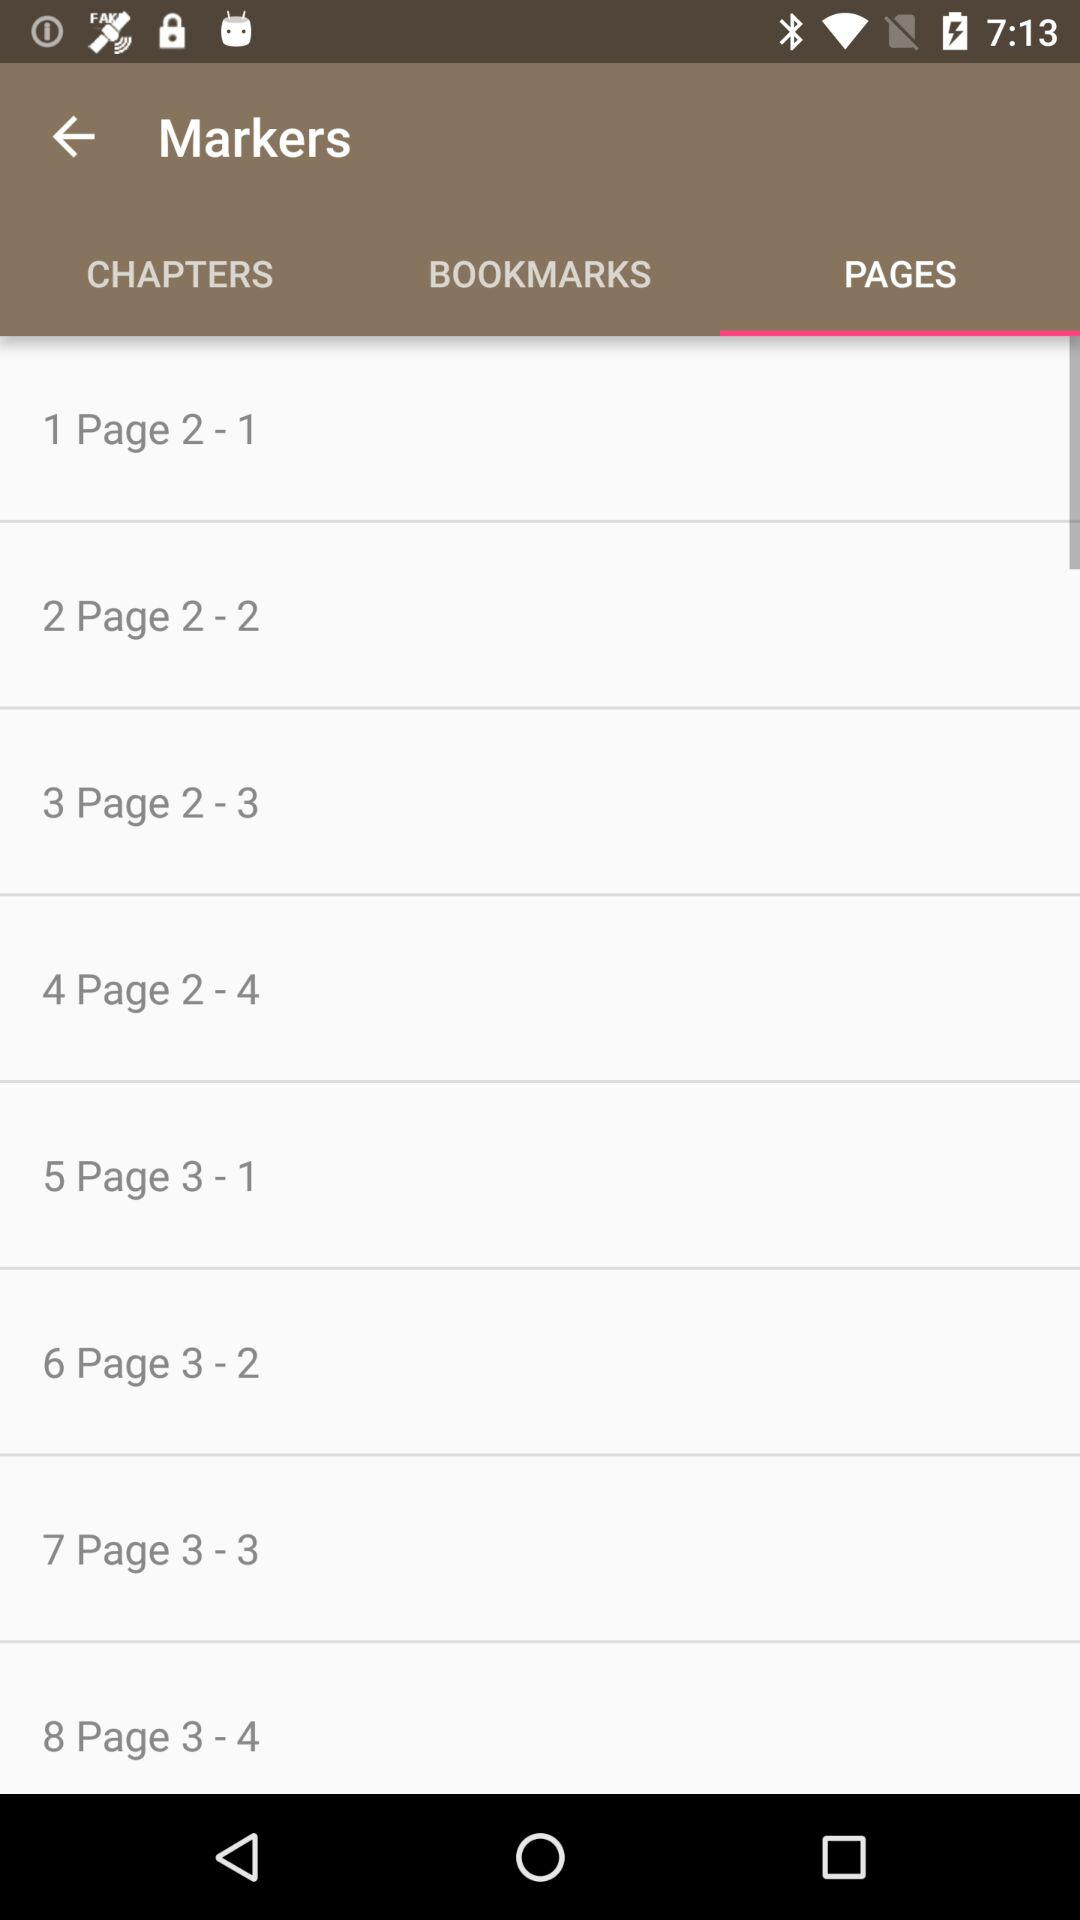Which tab is selected? The selected tab is "PAGES". 